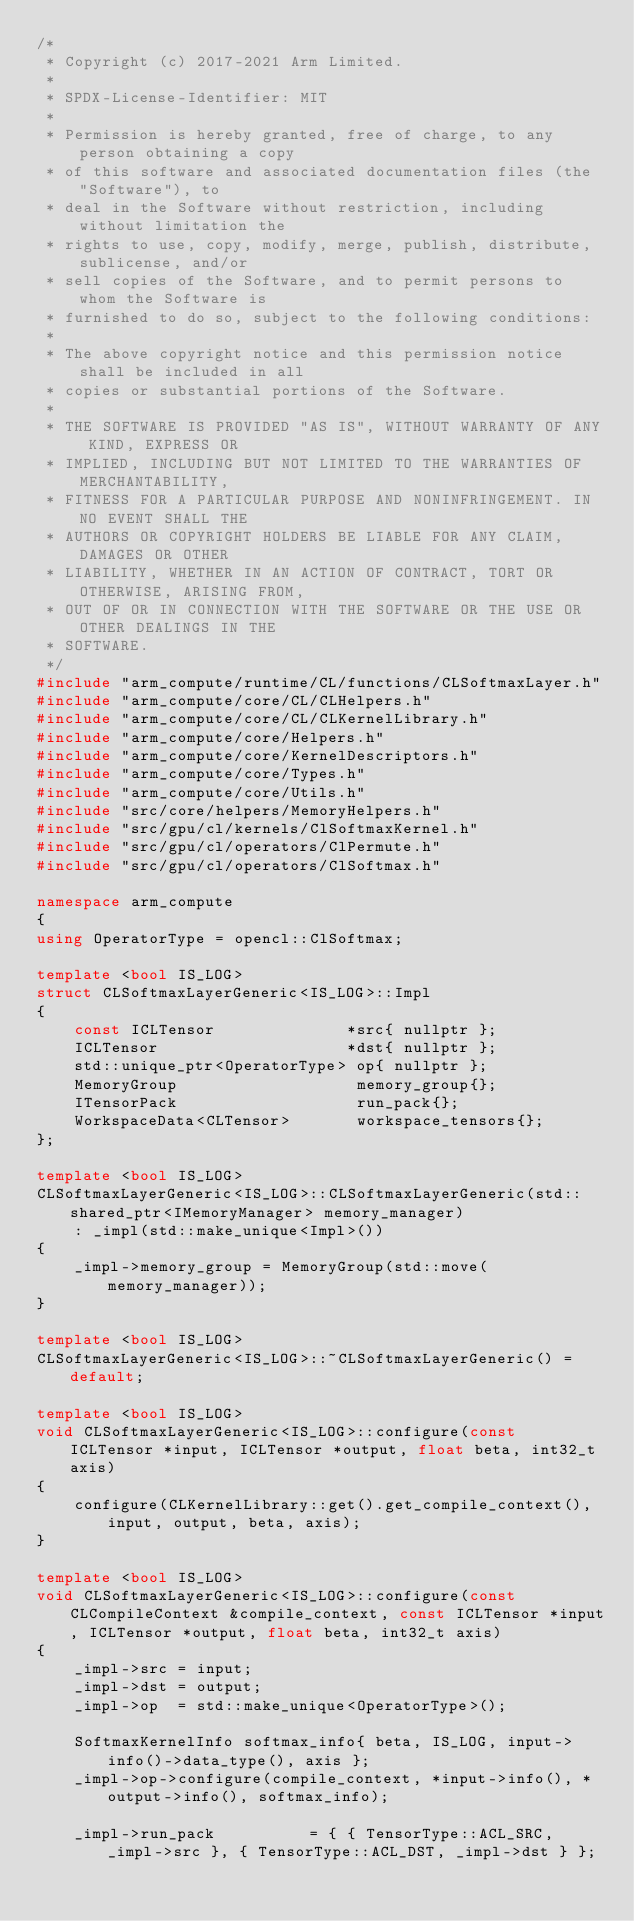Convert code to text. <code><loc_0><loc_0><loc_500><loc_500><_C++_>/*
 * Copyright (c) 2017-2021 Arm Limited.
 *
 * SPDX-License-Identifier: MIT
 *
 * Permission is hereby granted, free of charge, to any person obtaining a copy
 * of this software and associated documentation files (the "Software"), to
 * deal in the Software without restriction, including without limitation the
 * rights to use, copy, modify, merge, publish, distribute, sublicense, and/or
 * sell copies of the Software, and to permit persons to whom the Software is
 * furnished to do so, subject to the following conditions:
 *
 * The above copyright notice and this permission notice shall be included in all
 * copies or substantial portions of the Software.
 *
 * THE SOFTWARE IS PROVIDED "AS IS", WITHOUT WARRANTY OF ANY KIND, EXPRESS OR
 * IMPLIED, INCLUDING BUT NOT LIMITED TO THE WARRANTIES OF MERCHANTABILITY,
 * FITNESS FOR A PARTICULAR PURPOSE AND NONINFRINGEMENT. IN NO EVENT SHALL THE
 * AUTHORS OR COPYRIGHT HOLDERS BE LIABLE FOR ANY CLAIM, DAMAGES OR OTHER
 * LIABILITY, WHETHER IN AN ACTION OF CONTRACT, TORT OR OTHERWISE, ARISING FROM,
 * OUT OF OR IN CONNECTION WITH THE SOFTWARE OR THE USE OR OTHER DEALINGS IN THE
 * SOFTWARE.
 */
#include "arm_compute/runtime/CL/functions/CLSoftmaxLayer.h"
#include "arm_compute/core/CL/CLHelpers.h"
#include "arm_compute/core/CL/CLKernelLibrary.h"
#include "arm_compute/core/Helpers.h"
#include "arm_compute/core/KernelDescriptors.h"
#include "arm_compute/core/Types.h"
#include "arm_compute/core/Utils.h"
#include "src/core/helpers/MemoryHelpers.h"
#include "src/gpu/cl/kernels/ClSoftmaxKernel.h"
#include "src/gpu/cl/operators/ClPermute.h"
#include "src/gpu/cl/operators/ClSoftmax.h"

namespace arm_compute
{
using OperatorType = opencl::ClSoftmax;

template <bool IS_LOG>
struct CLSoftmaxLayerGeneric<IS_LOG>::Impl
{
    const ICLTensor              *src{ nullptr };
    ICLTensor                    *dst{ nullptr };
    std::unique_ptr<OperatorType> op{ nullptr };
    MemoryGroup                   memory_group{};
    ITensorPack                   run_pack{};
    WorkspaceData<CLTensor>       workspace_tensors{};
};

template <bool IS_LOG>
CLSoftmaxLayerGeneric<IS_LOG>::CLSoftmaxLayerGeneric(std::shared_ptr<IMemoryManager> memory_manager)
    : _impl(std::make_unique<Impl>())
{
    _impl->memory_group = MemoryGroup(std::move(memory_manager));
}

template <bool IS_LOG>
CLSoftmaxLayerGeneric<IS_LOG>::~CLSoftmaxLayerGeneric() = default;

template <bool IS_LOG>
void CLSoftmaxLayerGeneric<IS_LOG>::configure(const ICLTensor *input, ICLTensor *output, float beta, int32_t axis)
{
    configure(CLKernelLibrary::get().get_compile_context(), input, output, beta, axis);
}

template <bool IS_LOG>
void CLSoftmaxLayerGeneric<IS_LOG>::configure(const CLCompileContext &compile_context, const ICLTensor *input, ICLTensor *output, float beta, int32_t axis)
{
    _impl->src = input;
    _impl->dst = output;
    _impl->op  = std::make_unique<OperatorType>();

    SoftmaxKernelInfo softmax_info{ beta, IS_LOG, input->info()->data_type(), axis };
    _impl->op->configure(compile_context, *input->info(), *output->info(), softmax_info);

    _impl->run_pack          = { { TensorType::ACL_SRC, _impl->src }, { TensorType::ACL_DST, _impl->dst } };</code> 